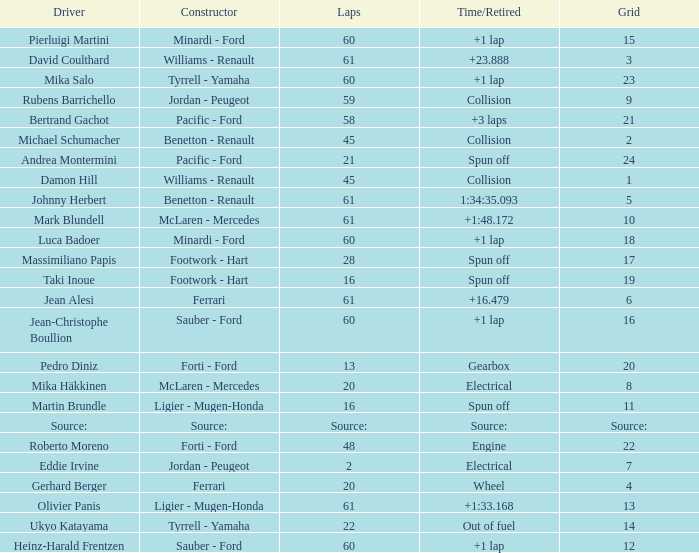What's the time/retired for a grid of 14? Out of fuel. 